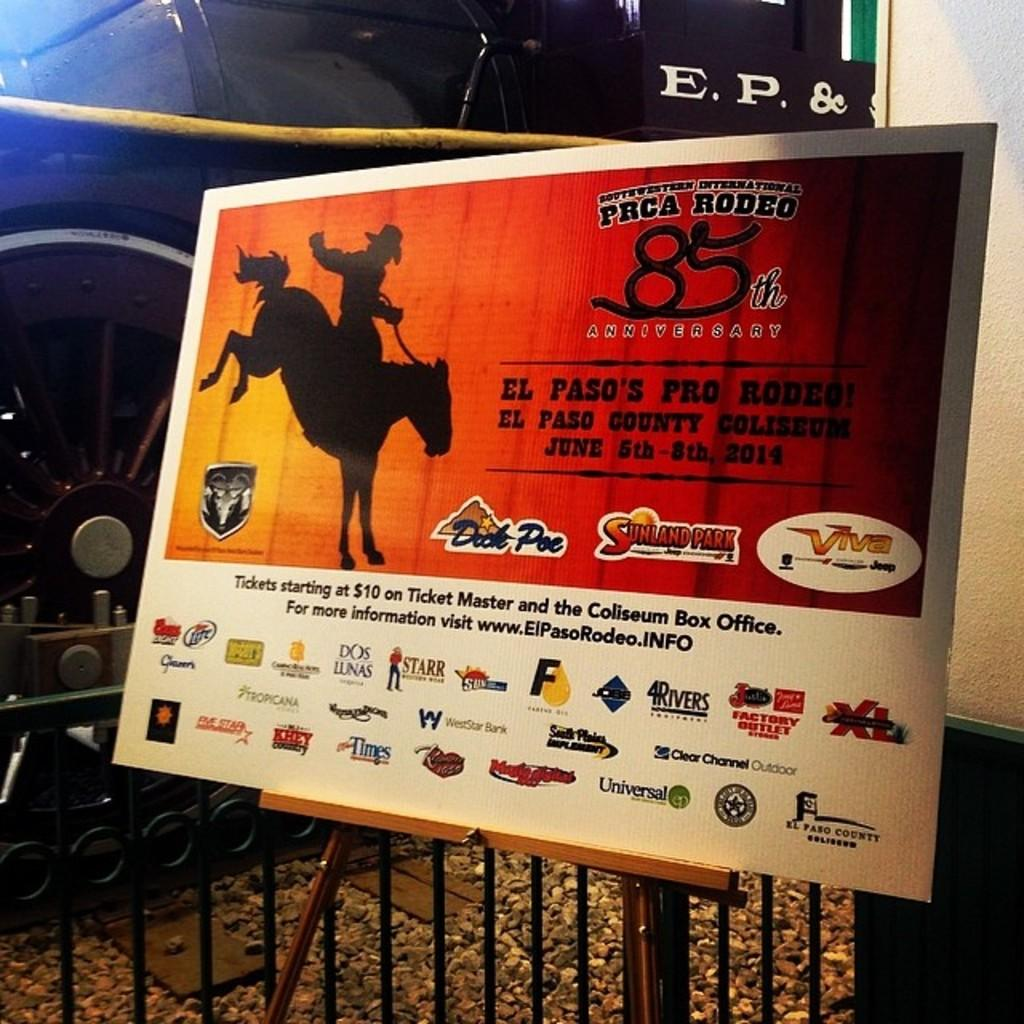<image>
Render a clear and concise summary of the photo. PRCA Rodeo billboard with sponsors at the bottom 